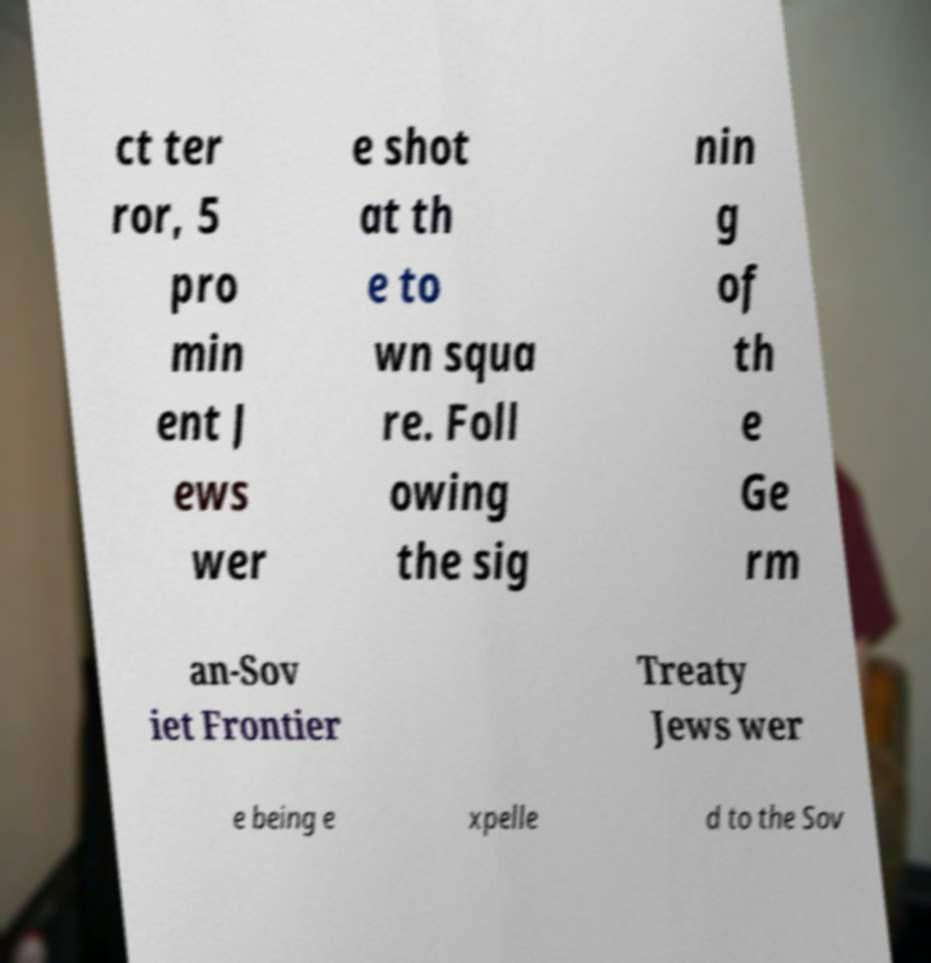Could you extract and type out the text from this image? ct ter ror, 5 pro min ent J ews wer e shot at th e to wn squa re. Foll owing the sig nin g of th e Ge rm an-Sov iet Frontier Treaty Jews wer e being e xpelle d to the Sov 